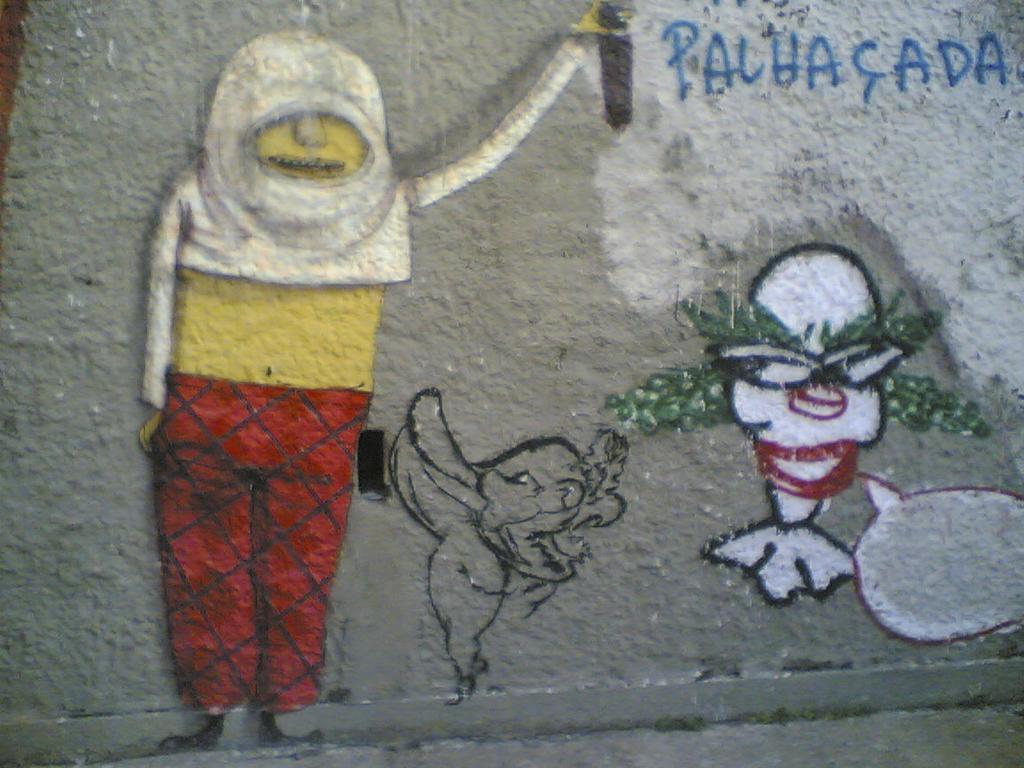Could you give a brief overview of what you see in this image? In this picture we can see a wall and on the wall there are paintings and letters. 